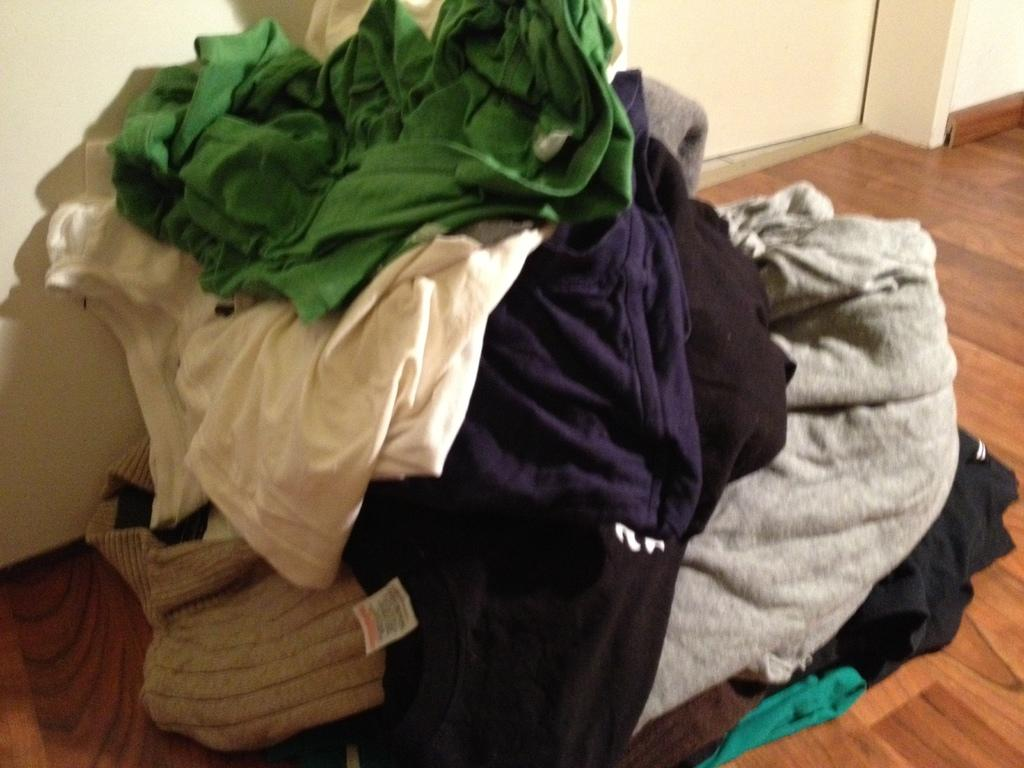What is on the floor in the image? There are clothes on the floor in the image. What type of hose is being used to clean the clothes on the floor in the image? There is no hose present in the image, and the clothes on the floor do not appear to be wet or in need of cleaning. 